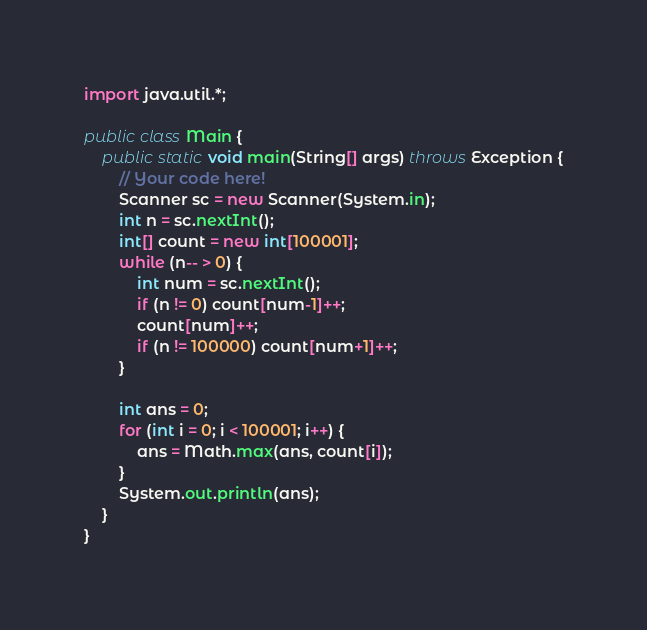<code> <loc_0><loc_0><loc_500><loc_500><_Java_>import java.util.*;

public class Main {
    public static void main(String[] args) throws Exception {
        // Your code here!
        Scanner sc = new Scanner(System.in);
        int n = sc.nextInt();
        int[] count = new int[100001];
        while (n-- > 0) {
            int num = sc.nextInt();
            if (n != 0) count[num-1]++;
            count[num]++;
            if (n != 100000) count[num+1]++;
        }
        
        int ans = 0;
        for (int i = 0; i < 100001; i++) {
            ans = Math.max(ans, count[i]);
        }
        System.out.println(ans);
    }
}
</code> 